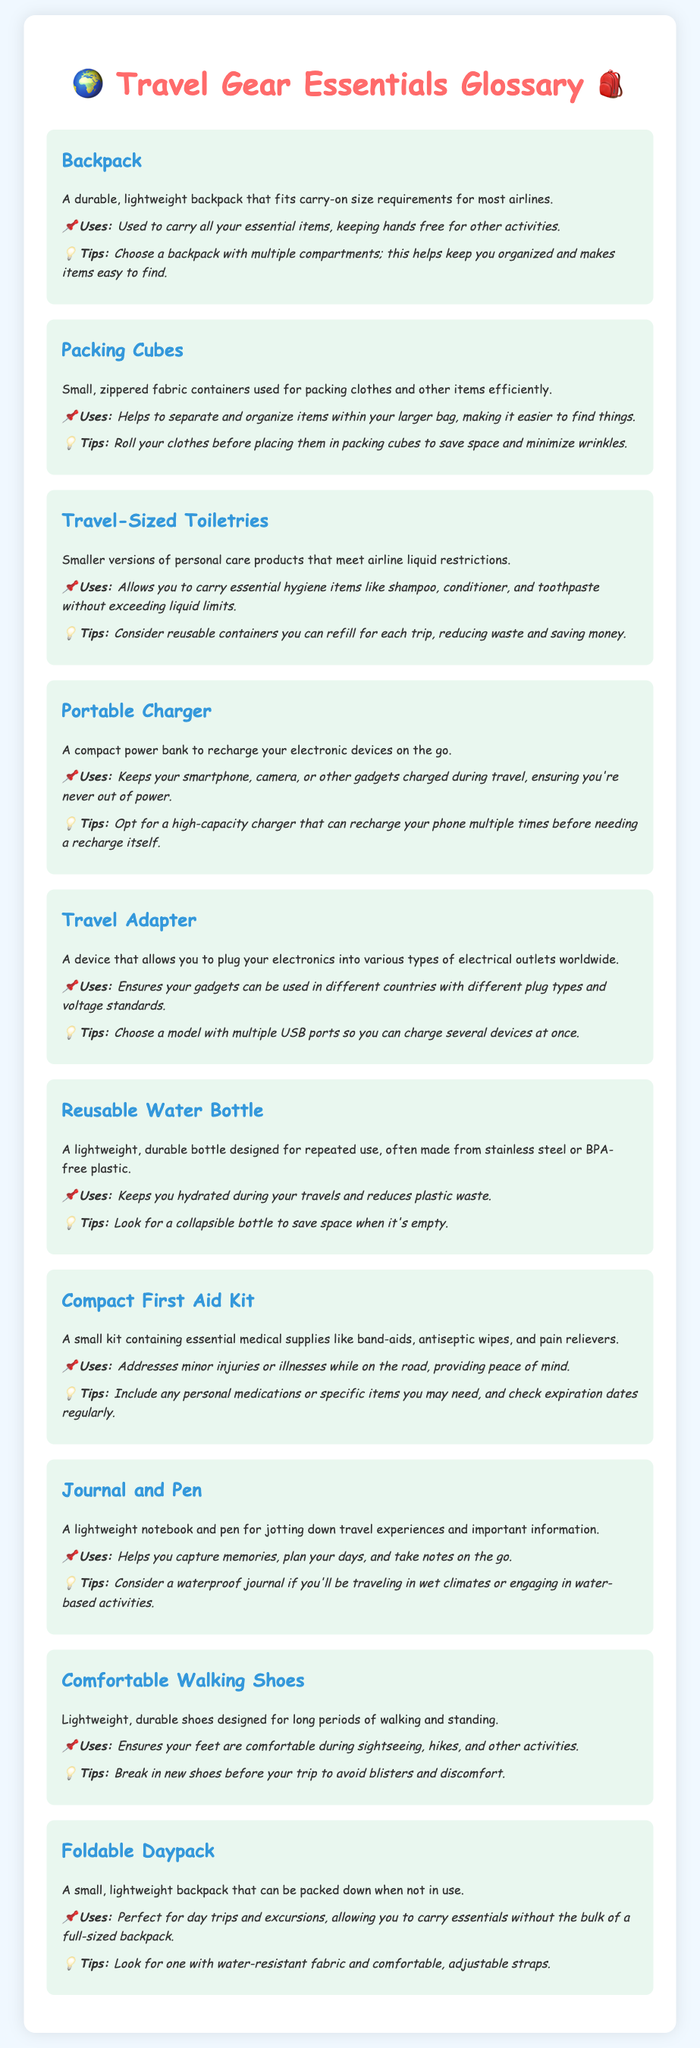What is a durable, lightweight backpack? A durable, lightweight backpack that fits carry-on size requirements for most airlines.
Answer: Backpack What do packing cubes help with? Helps to separate and organize items within your larger bag, making it easier to find things.
Answer: Organizing items What is the use of travel-sized toiletries? Allows you to carry essential hygiene items like shampoo, conditioner, and toothpaste without exceeding liquid limits.
Answer: Hygiene items What is a compact power bank used for? Keeps your smartphone, camera, or other gadgets charged during travel, ensuring you're never out of power.
Answer: Recharge gadgets What should you look for in a travel adapter? Choose a model with multiple USB ports so you can charge several devices at once.
Answer: Multiple USB ports Why should you break in new shoes before your trip? To avoid blisters and discomfort.
Answer: Avoid blisters What type of journal is recommended for wet climates? Consider a waterproof journal if you'll be traveling in wet climates or engaging in water-based activities.
Answer: Waterproof journal What type of bottle helps reduce plastic waste? A lightweight, durable bottle designed for repeated use, often made from stainless steel or BPA-free plastic.
Answer: Reusable Water Bottle What is a foldable daypack ideal for? Perfect for day trips and excursions, allowing you to carry essentials without the bulk of a full-sized backpack.
Answer: Day trips 